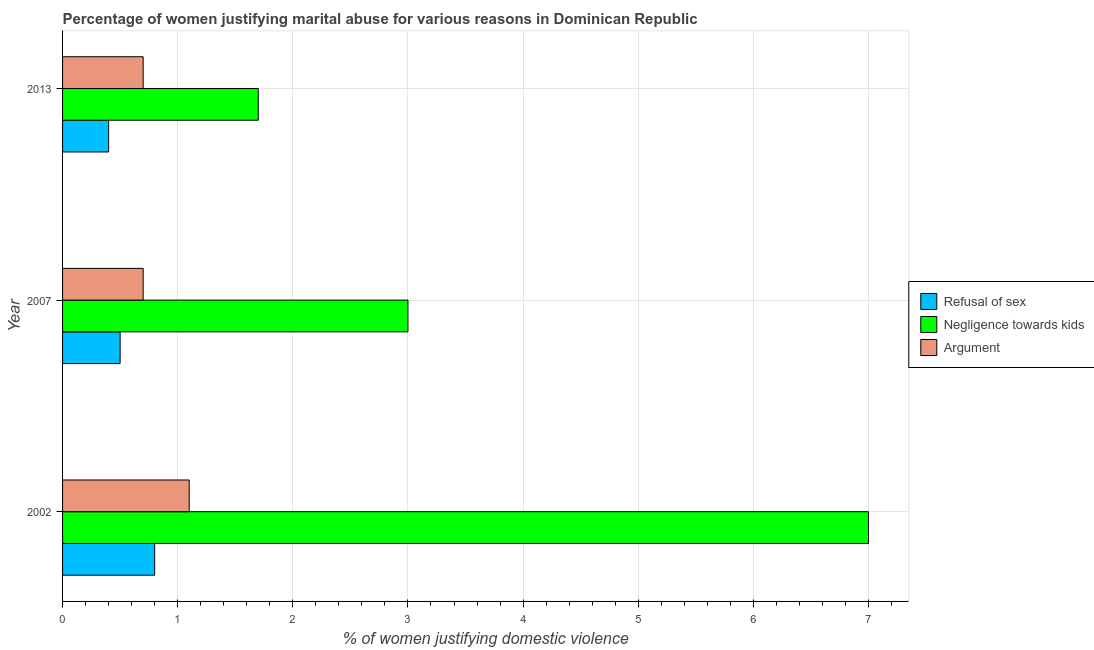How many different coloured bars are there?
Provide a succinct answer. 3. Are the number of bars per tick equal to the number of legend labels?
Give a very brief answer. Yes. How many bars are there on the 3rd tick from the top?
Provide a succinct answer. 3. How many bars are there on the 1st tick from the bottom?
Keep it short and to the point. 3. What is the percentage of women justifying domestic violence due to arguments in 2013?
Give a very brief answer. 0.7. Across all years, what is the minimum percentage of women justifying domestic violence due to arguments?
Your answer should be very brief. 0.7. In which year was the percentage of women justifying domestic violence due to negligence towards kids maximum?
Your response must be concise. 2002. What is the difference between the percentage of women justifying domestic violence due to refusal of sex in 2007 and the percentage of women justifying domestic violence due to negligence towards kids in 2002?
Your answer should be compact. -6.5. What is the average percentage of women justifying domestic violence due to arguments per year?
Your answer should be compact. 0.83. In how many years, is the percentage of women justifying domestic violence due to negligence towards kids greater than 5 %?
Keep it short and to the point. 1. What is the ratio of the percentage of women justifying domestic violence due to refusal of sex in 2007 to that in 2013?
Your answer should be compact. 1.25. Is the difference between the percentage of women justifying domestic violence due to negligence towards kids in 2002 and 2007 greater than the difference between the percentage of women justifying domestic violence due to refusal of sex in 2002 and 2007?
Your response must be concise. Yes. What is the difference between the highest and the lowest percentage of women justifying domestic violence due to refusal of sex?
Your answer should be compact. 0.4. In how many years, is the percentage of women justifying domestic violence due to arguments greater than the average percentage of women justifying domestic violence due to arguments taken over all years?
Offer a terse response. 1. Is the sum of the percentage of women justifying domestic violence due to arguments in 2002 and 2007 greater than the maximum percentage of women justifying domestic violence due to refusal of sex across all years?
Provide a succinct answer. Yes. What does the 2nd bar from the top in 2007 represents?
Ensure brevity in your answer.  Negligence towards kids. What does the 3rd bar from the bottom in 2002 represents?
Your answer should be very brief. Argument. Is it the case that in every year, the sum of the percentage of women justifying domestic violence due to refusal of sex and percentage of women justifying domestic violence due to negligence towards kids is greater than the percentage of women justifying domestic violence due to arguments?
Offer a terse response. Yes. How many years are there in the graph?
Your response must be concise. 3. Are the values on the major ticks of X-axis written in scientific E-notation?
Ensure brevity in your answer.  No. How many legend labels are there?
Provide a short and direct response. 3. What is the title of the graph?
Make the answer very short. Percentage of women justifying marital abuse for various reasons in Dominican Republic. What is the label or title of the X-axis?
Offer a very short reply. % of women justifying domestic violence. What is the label or title of the Y-axis?
Your answer should be compact. Year. What is the % of women justifying domestic violence of Refusal of sex in 2002?
Offer a very short reply. 0.8. What is the % of women justifying domestic violence in Negligence towards kids in 2002?
Your answer should be compact. 7. What is the % of women justifying domestic violence of Negligence towards kids in 2007?
Offer a very short reply. 3. What is the % of women justifying domestic violence of Argument in 2007?
Offer a terse response. 0.7. What is the % of women justifying domestic violence in Refusal of sex in 2013?
Offer a very short reply. 0.4. What is the % of women justifying domestic violence in Argument in 2013?
Provide a short and direct response. 0.7. Across all years, what is the maximum % of women justifying domestic violence of Refusal of sex?
Your answer should be compact. 0.8. Across all years, what is the maximum % of women justifying domestic violence in Negligence towards kids?
Keep it short and to the point. 7. Across all years, what is the minimum % of women justifying domestic violence in Negligence towards kids?
Make the answer very short. 1.7. Across all years, what is the minimum % of women justifying domestic violence in Argument?
Provide a short and direct response. 0.7. What is the total % of women justifying domestic violence of Refusal of sex in the graph?
Provide a succinct answer. 1.7. What is the total % of women justifying domestic violence in Argument in the graph?
Keep it short and to the point. 2.5. What is the difference between the % of women justifying domestic violence in Refusal of sex in 2002 and that in 2007?
Keep it short and to the point. 0.3. What is the difference between the % of women justifying domestic violence in Argument in 2002 and that in 2007?
Your answer should be compact. 0.4. What is the difference between the % of women justifying domestic violence in Refusal of sex in 2002 and that in 2013?
Keep it short and to the point. 0.4. What is the difference between the % of women justifying domestic violence of Negligence towards kids in 2002 and that in 2013?
Your answer should be very brief. 5.3. What is the difference between the % of women justifying domestic violence in Argument in 2002 and that in 2013?
Your answer should be compact. 0.4. What is the difference between the % of women justifying domestic violence of Refusal of sex in 2007 and that in 2013?
Give a very brief answer. 0.1. What is the difference between the % of women justifying domestic violence in Argument in 2007 and that in 2013?
Your answer should be very brief. 0. What is the difference between the % of women justifying domestic violence in Refusal of sex in 2002 and the % of women justifying domestic violence in Argument in 2007?
Your response must be concise. 0.1. What is the difference between the % of women justifying domestic violence of Negligence towards kids in 2002 and the % of women justifying domestic violence of Argument in 2007?
Keep it short and to the point. 6.3. What is the difference between the % of women justifying domestic violence of Refusal of sex in 2002 and the % of women justifying domestic violence of Negligence towards kids in 2013?
Your response must be concise. -0.9. What is the difference between the % of women justifying domestic violence in Negligence towards kids in 2002 and the % of women justifying domestic violence in Argument in 2013?
Offer a very short reply. 6.3. What is the difference between the % of women justifying domestic violence of Refusal of sex in 2007 and the % of women justifying domestic violence of Negligence towards kids in 2013?
Offer a terse response. -1.2. What is the difference between the % of women justifying domestic violence in Negligence towards kids in 2007 and the % of women justifying domestic violence in Argument in 2013?
Make the answer very short. 2.3. What is the average % of women justifying domestic violence of Refusal of sex per year?
Keep it short and to the point. 0.57. In the year 2002, what is the difference between the % of women justifying domestic violence of Negligence towards kids and % of women justifying domestic violence of Argument?
Offer a very short reply. 5.9. In the year 2007, what is the difference between the % of women justifying domestic violence of Refusal of sex and % of women justifying domestic violence of Negligence towards kids?
Your answer should be compact. -2.5. In the year 2007, what is the difference between the % of women justifying domestic violence of Negligence towards kids and % of women justifying domestic violence of Argument?
Your answer should be compact. 2.3. In the year 2013, what is the difference between the % of women justifying domestic violence of Refusal of sex and % of women justifying domestic violence of Negligence towards kids?
Your answer should be very brief. -1.3. What is the ratio of the % of women justifying domestic violence of Negligence towards kids in 2002 to that in 2007?
Provide a short and direct response. 2.33. What is the ratio of the % of women justifying domestic violence in Argument in 2002 to that in 2007?
Offer a terse response. 1.57. What is the ratio of the % of women justifying domestic violence in Negligence towards kids in 2002 to that in 2013?
Ensure brevity in your answer.  4.12. What is the ratio of the % of women justifying domestic violence in Argument in 2002 to that in 2013?
Make the answer very short. 1.57. What is the ratio of the % of women justifying domestic violence of Refusal of sex in 2007 to that in 2013?
Offer a terse response. 1.25. What is the ratio of the % of women justifying domestic violence in Negligence towards kids in 2007 to that in 2013?
Offer a terse response. 1.76. What is the ratio of the % of women justifying domestic violence of Argument in 2007 to that in 2013?
Ensure brevity in your answer.  1. What is the difference between the highest and the second highest % of women justifying domestic violence of Refusal of sex?
Your answer should be compact. 0.3. What is the difference between the highest and the second highest % of women justifying domestic violence in Negligence towards kids?
Ensure brevity in your answer.  4. What is the difference between the highest and the lowest % of women justifying domestic violence of Argument?
Your answer should be very brief. 0.4. 